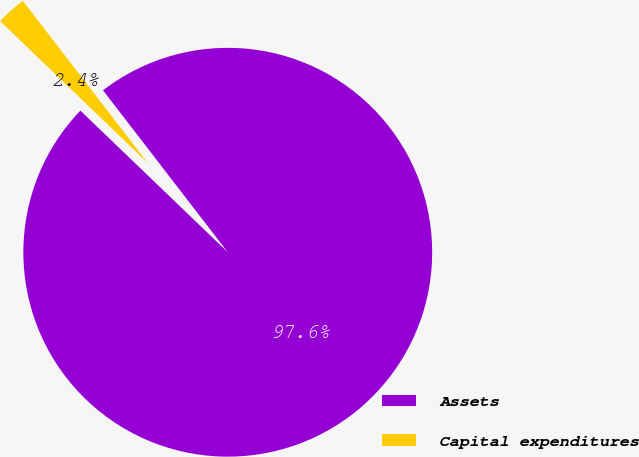Convert chart to OTSL. <chart><loc_0><loc_0><loc_500><loc_500><pie_chart><fcel>Assets<fcel>Capital expenditures<nl><fcel>97.63%<fcel>2.37%<nl></chart> 